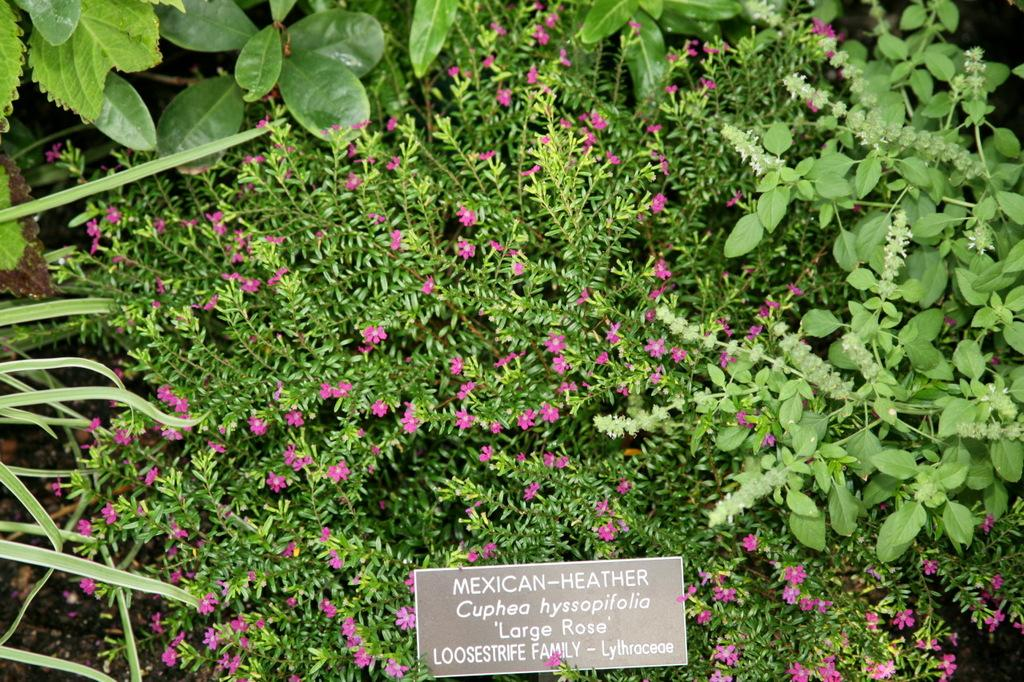What type of living organisms can be seen in the image? There are flowers and plants visible in the image. What else is present in the image besides the living organisms? There is a board with text in the image. What type of jewel is hanging from the flowers in the image? There is no jewel present in the image; it features flowers and plants with a board containing text. 